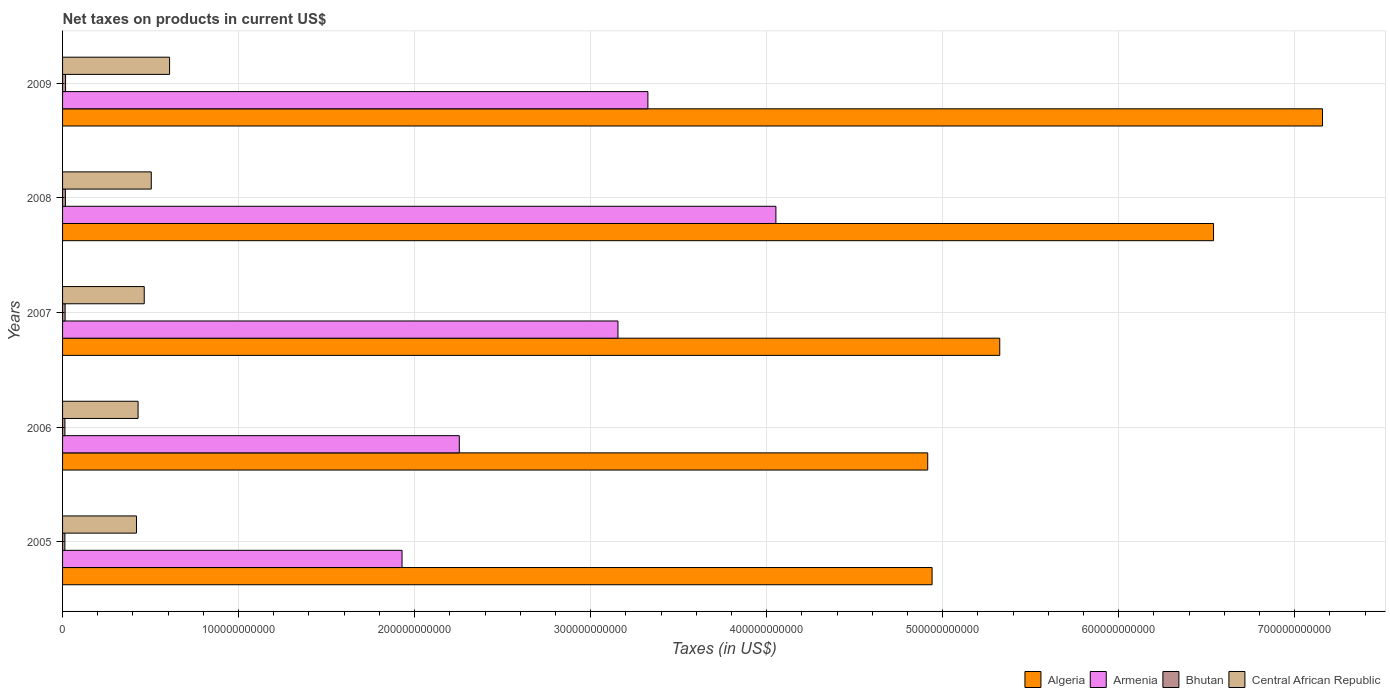How many different coloured bars are there?
Make the answer very short. 4. Are the number of bars on each tick of the Y-axis equal?
Offer a very short reply. Yes. How many bars are there on the 4th tick from the bottom?
Your answer should be very brief. 4. What is the label of the 4th group of bars from the top?
Provide a succinct answer. 2006. In how many cases, is the number of bars for a given year not equal to the number of legend labels?
Offer a very short reply. 0. What is the net taxes on products in Central African Republic in 2008?
Provide a succinct answer. 5.04e+1. Across all years, what is the maximum net taxes on products in Algeria?
Provide a succinct answer. 7.16e+11. Across all years, what is the minimum net taxes on products in Central African Republic?
Your response must be concise. 4.20e+1. What is the total net taxes on products in Bhutan in the graph?
Offer a terse response. 7.42e+09. What is the difference between the net taxes on products in Central African Republic in 2005 and that in 2006?
Your answer should be compact. -9.00e+08. What is the difference between the net taxes on products in Armenia in 2006 and the net taxes on products in Algeria in 2008?
Ensure brevity in your answer.  -4.29e+11. What is the average net taxes on products in Bhutan per year?
Give a very brief answer. 1.48e+09. In the year 2007, what is the difference between the net taxes on products in Bhutan and net taxes on products in Algeria?
Offer a very short reply. -5.31e+11. In how many years, is the net taxes on products in Armenia greater than 540000000000 US$?
Your answer should be compact. 0. What is the ratio of the net taxes on products in Armenia in 2007 to that in 2008?
Offer a terse response. 0.78. What is the difference between the highest and the second highest net taxes on products in Central African Republic?
Make the answer very short. 1.04e+1. What is the difference between the highest and the lowest net taxes on products in Armenia?
Your answer should be very brief. 2.12e+11. In how many years, is the net taxes on products in Armenia greater than the average net taxes on products in Armenia taken over all years?
Keep it short and to the point. 3. Is the sum of the net taxes on products in Armenia in 2006 and 2007 greater than the maximum net taxes on products in Central African Republic across all years?
Your answer should be very brief. Yes. What does the 1st bar from the top in 2009 represents?
Your answer should be very brief. Central African Republic. What does the 3rd bar from the bottom in 2006 represents?
Ensure brevity in your answer.  Bhutan. Are all the bars in the graph horizontal?
Keep it short and to the point. Yes. How many years are there in the graph?
Offer a very short reply. 5. What is the difference between two consecutive major ticks on the X-axis?
Your answer should be very brief. 1.00e+11. Are the values on the major ticks of X-axis written in scientific E-notation?
Ensure brevity in your answer.  No. Does the graph contain grids?
Ensure brevity in your answer.  Yes. How many legend labels are there?
Offer a terse response. 4. How are the legend labels stacked?
Keep it short and to the point. Horizontal. What is the title of the graph?
Provide a succinct answer. Net taxes on products in current US$. Does "Belgium" appear as one of the legend labels in the graph?
Your response must be concise. No. What is the label or title of the X-axis?
Make the answer very short. Taxes (in US$). What is the label or title of the Y-axis?
Give a very brief answer. Years. What is the Taxes (in US$) of Algeria in 2005?
Offer a very short reply. 4.94e+11. What is the Taxes (in US$) of Armenia in 2005?
Provide a short and direct response. 1.93e+11. What is the Taxes (in US$) in Bhutan in 2005?
Your response must be concise. 1.32e+09. What is the Taxes (in US$) of Central African Republic in 2005?
Provide a succinct answer. 4.20e+1. What is the Taxes (in US$) of Algeria in 2006?
Your response must be concise. 4.92e+11. What is the Taxes (in US$) in Armenia in 2006?
Make the answer very short. 2.25e+11. What is the Taxes (in US$) in Bhutan in 2006?
Offer a very short reply. 1.34e+09. What is the Taxes (in US$) of Central African Republic in 2006?
Keep it short and to the point. 4.29e+1. What is the Taxes (in US$) in Algeria in 2007?
Your response must be concise. 5.32e+11. What is the Taxes (in US$) in Armenia in 2007?
Your answer should be compact. 3.16e+11. What is the Taxes (in US$) in Bhutan in 2007?
Provide a succinct answer. 1.44e+09. What is the Taxes (in US$) in Central African Republic in 2007?
Your answer should be compact. 4.64e+1. What is the Taxes (in US$) of Algeria in 2008?
Your answer should be very brief. 6.54e+11. What is the Taxes (in US$) in Armenia in 2008?
Make the answer very short. 4.05e+11. What is the Taxes (in US$) of Bhutan in 2008?
Offer a terse response. 1.61e+09. What is the Taxes (in US$) of Central African Republic in 2008?
Make the answer very short. 5.04e+1. What is the Taxes (in US$) of Algeria in 2009?
Provide a succinct answer. 7.16e+11. What is the Taxes (in US$) of Armenia in 2009?
Offer a very short reply. 3.33e+11. What is the Taxes (in US$) in Bhutan in 2009?
Ensure brevity in your answer.  1.70e+09. What is the Taxes (in US$) of Central African Republic in 2009?
Make the answer very short. 6.08e+1. Across all years, what is the maximum Taxes (in US$) of Algeria?
Give a very brief answer. 7.16e+11. Across all years, what is the maximum Taxes (in US$) of Armenia?
Your answer should be very brief. 4.05e+11. Across all years, what is the maximum Taxes (in US$) of Bhutan?
Offer a very short reply. 1.70e+09. Across all years, what is the maximum Taxes (in US$) of Central African Republic?
Keep it short and to the point. 6.08e+1. Across all years, what is the minimum Taxes (in US$) in Algeria?
Offer a terse response. 4.92e+11. Across all years, what is the minimum Taxes (in US$) in Armenia?
Offer a very short reply. 1.93e+11. Across all years, what is the minimum Taxes (in US$) in Bhutan?
Keep it short and to the point. 1.32e+09. Across all years, what is the minimum Taxes (in US$) in Central African Republic?
Make the answer very short. 4.20e+1. What is the total Taxes (in US$) in Algeria in the graph?
Offer a very short reply. 2.89e+12. What is the total Taxes (in US$) in Armenia in the graph?
Offer a terse response. 1.47e+12. What is the total Taxes (in US$) in Bhutan in the graph?
Make the answer very short. 7.42e+09. What is the total Taxes (in US$) in Central African Republic in the graph?
Offer a terse response. 2.42e+11. What is the difference between the Taxes (in US$) in Algeria in 2005 and that in 2006?
Ensure brevity in your answer.  2.48e+09. What is the difference between the Taxes (in US$) of Armenia in 2005 and that in 2006?
Offer a terse response. -3.25e+1. What is the difference between the Taxes (in US$) in Bhutan in 2005 and that in 2006?
Provide a succinct answer. -1.97e+07. What is the difference between the Taxes (in US$) of Central African Republic in 2005 and that in 2006?
Offer a very short reply. -9.00e+08. What is the difference between the Taxes (in US$) in Algeria in 2005 and that in 2007?
Give a very brief answer. -3.84e+1. What is the difference between the Taxes (in US$) of Armenia in 2005 and that in 2007?
Offer a very short reply. -1.23e+11. What is the difference between the Taxes (in US$) of Bhutan in 2005 and that in 2007?
Provide a short and direct response. -1.25e+08. What is the difference between the Taxes (in US$) of Central African Republic in 2005 and that in 2007?
Give a very brief answer. -4.40e+09. What is the difference between the Taxes (in US$) of Algeria in 2005 and that in 2008?
Your response must be concise. -1.60e+11. What is the difference between the Taxes (in US$) in Armenia in 2005 and that in 2008?
Give a very brief answer. -2.12e+11. What is the difference between the Taxes (in US$) in Bhutan in 2005 and that in 2008?
Provide a succinct answer. -2.95e+08. What is the difference between the Taxes (in US$) of Central African Republic in 2005 and that in 2008?
Keep it short and to the point. -8.40e+09. What is the difference between the Taxes (in US$) of Algeria in 2005 and that in 2009?
Your answer should be compact. -2.22e+11. What is the difference between the Taxes (in US$) in Armenia in 2005 and that in 2009?
Make the answer very short. -1.40e+11. What is the difference between the Taxes (in US$) in Bhutan in 2005 and that in 2009?
Give a very brief answer. -3.87e+08. What is the difference between the Taxes (in US$) in Central African Republic in 2005 and that in 2009?
Your answer should be very brief. -1.88e+1. What is the difference between the Taxes (in US$) of Algeria in 2006 and that in 2007?
Offer a very short reply. -4.09e+1. What is the difference between the Taxes (in US$) of Armenia in 2006 and that in 2007?
Make the answer very short. -9.01e+1. What is the difference between the Taxes (in US$) of Bhutan in 2006 and that in 2007?
Offer a terse response. -1.05e+08. What is the difference between the Taxes (in US$) in Central African Republic in 2006 and that in 2007?
Offer a terse response. -3.50e+09. What is the difference between the Taxes (in US$) in Algeria in 2006 and that in 2008?
Your response must be concise. -1.62e+11. What is the difference between the Taxes (in US$) in Armenia in 2006 and that in 2008?
Provide a succinct answer. -1.80e+11. What is the difference between the Taxes (in US$) in Bhutan in 2006 and that in 2008?
Offer a very short reply. -2.76e+08. What is the difference between the Taxes (in US$) in Central African Republic in 2006 and that in 2008?
Make the answer very short. -7.50e+09. What is the difference between the Taxes (in US$) of Algeria in 2006 and that in 2009?
Keep it short and to the point. -2.24e+11. What is the difference between the Taxes (in US$) of Armenia in 2006 and that in 2009?
Provide a short and direct response. -1.07e+11. What is the difference between the Taxes (in US$) in Bhutan in 2006 and that in 2009?
Provide a short and direct response. -3.67e+08. What is the difference between the Taxes (in US$) in Central African Republic in 2006 and that in 2009?
Your answer should be compact. -1.79e+1. What is the difference between the Taxes (in US$) of Algeria in 2007 and that in 2008?
Offer a terse response. -1.21e+11. What is the difference between the Taxes (in US$) in Armenia in 2007 and that in 2008?
Provide a short and direct response. -8.97e+1. What is the difference between the Taxes (in US$) in Bhutan in 2007 and that in 2008?
Provide a short and direct response. -1.71e+08. What is the difference between the Taxes (in US$) in Central African Republic in 2007 and that in 2008?
Offer a very short reply. -4.00e+09. What is the difference between the Taxes (in US$) of Algeria in 2007 and that in 2009?
Make the answer very short. -1.83e+11. What is the difference between the Taxes (in US$) in Armenia in 2007 and that in 2009?
Provide a succinct answer. -1.70e+1. What is the difference between the Taxes (in US$) of Bhutan in 2007 and that in 2009?
Provide a succinct answer. -2.62e+08. What is the difference between the Taxes (in US$) of Central African Republic in 2007 and that in 2009?
Provide a succinct answer. -1.44e+1. What is the difference between the Taxes (in US$) in Algeria in 2008 and that in 2009?
Your response must be concise. -6.19e+1. What is the difference between the Taxes (in US$) in Armenia in 2008 and that in 2009?
Your answer should be very brief. 7.27e+1. What is the difference between the Taxes (in US$) of Bhutan in 2008 and that in 2009?
Keep it short and to the point. -9.18e+07. What is the difference between the Taxes (in US$) in Central African Republic in 2008 and that in 2009?
Provide a short and direct response. -1.04e+1. What is the difference between the Taxes (in US$) in Algeria in 2005 and the Taxes (in US$) in Armenia in 2006?
Keep it short and to the point. 2.69e+11. What is the difference between the Taxes (in US$) in Algeria in 2005 and the Taxes (in US$) in Bhutan in 2006?
Give a very brief answer. 4.93e+11. What is the difference between the Taxes (in US$) of Algeria in 2005 and the Taxes (in US$) of Central African Republic in 2006?
Offer a very short reply. 4.51e+11. What is the difference between the Taxes (in US$) in Armenia in 2005 and the Taxes (in US$) in Bhutan in 2006?
Keep it short and to the point. 1.92e+11. What is the difference between the Taxes (in US$) in Armenia in 2005 and the Taxes (in US$) in Central African Republic in 2006?
Offer a very short reply. 1.50e+11. What is the difference between the Taxes (in US$) in Bhutan in 2005 and the Taxes (in US$) in Central African Republic in 2006?
Ensure brevity in your answer.  -4.16e+1. What is the difference between the Taxes (in US$) in Algeria in 2005 and the Taxes (in US$) in Armenia in 2007?
Your answer should be very brief. 1.78e+11. What is the difference between the Taxes (in US$) in Algeria in 2005 and the Taxes (in US$) in Bhutan in 2007?
Offer a terse response. 4.93e+11. What is the difference between the Taxes (in US$) in Algeria in 2005 and the Taxes (in US$) in Central African Republic in 2007?
Offer a very short reply. 4.48e+11. What is the difference between the Taxes (in US$) in Armenia in 2005 and the Taxes (in US$) in Bhutan in 2007?
Your answer should be compact. 1.91e+11. What is the difference between the Taxes (in US$) of Armenia in 2005 and the Taxes (in US$) of Central African Republic in 2007?
Give a very brief answer. 1.46e+11. What is the difference between the Taxes (in US$) in Bhutan in 2005 and the Taxes (in US$) in Central African Republic in 2007?
Give a very brief answer. -4.51e+1. What is the difference between the Taxes (in US$) of Algeria in 2005 and the Taxes (in US$) of Armenia in 2008?
Provide a short and direct response. 8.87e+1. What is the difference between the Taxes (in US$) in Algeria in 2005 and the Taxes (in US$) in Bhutan in 2008?
Give a very brief answer. 4.92e+11. What is the difference between the Taxes (in US$) in Algeria in 2005 and the Taxes (in US$) in Central African Republic in 2008?
Your response must be concise. 4.44e+11. What is the difference between the Taxes (in US$) in Armenia in 2005 and the Taxes (in US$) in Bhutan in 2008?
Your response must be concise. 1.91e+11. What is the difference between the Taxes (in US$) of Armenia in 2005 and the Taxes (in US$) of Central African Republic in 2008?
Provide a short and direct response. 1.42e+11. What is the difference between the Taxes (in US$) of Bhutan in 2005 and the Taxes (in US$) of Central African Republic in 2008?
Keep it short and to the point. -4.91e+1. What is the difference between the Taxes (in US$) in Algeria in 2005 and the Taxes (in US$) in Armenia in 2009?
Ensure brevity in your answer.  1.61e+11. What is the difference between the Taxes (in US$) of Algeria in 2005 and the Taxes (in US$) of Bhutan in 2009?
Your response must be concise. 4.92e+11. What is the difference between the Taxes (in US$) of Algeria in 2005 and the Taxes (in US$) of Central African Republic in 2009?
Make the answer very short. 4.33e+11. What is the difference between the Taxes (in US$) of Armenia in 2005 and the Taxes (in US$) of Bhutan in 2009?
Provide a short and direct response. 1.91e+11. What is the difference between the Taxes (in US$) in Armenia in 2005 and the Taxes (in US$) in Central African Republic in 2009?
Make the answer very short. 1.32e+11. What is the difference between the Taxes (in US$) of Bhutan in 2005 and the Taxes (in US$) of Central African Republic in 2009?
Keep it short and to the point. -5.95e+1. What is the difference between the Taxes (in US$) of Algeria in 2006 and the Taxes (in US$) of Armenia in 2007?
Your answer should be compact. 1.76e+11. What is the difference between the Taxes (in US$) of Algeria in 2006 and the Taxes (in US$) of Bhutan in 2007?
Provide a short and direct response. 4.90e+11. What is the difference between the Taxes (in US$) of Algeria in 2006 and the Taxes (in US$) of Central African Republic in 2007?
Ensure brevity in your answer.  4.45e+11. What is the difference between the Taxes (in US$) of Armenia in 2006 and the Taxes (in US$) of Bhutan in 2007?
Provide a short and direct response. 2.24e+11. What is the difference between the Taxes (in US$) of Armenia in 2006 and the Taxes (in US$) of Central African Republic in 2007?
Make the answer very short. 1.79e+11. What is the difference between the Taxes (in US$) in Bhutan in 2006 and the Taxes (in US$) in Central African Republic in 2007?
Provide a short and direct response. -4.51e+1. What is the difference between the Taxes (in US$) of Algeria in 2006 and the Taxes (in US$) of Armenia in 2008?
Give a very brief answer. 8.63e+1. What is the difference between the Taxes (in US$) of Algeria in 2006 and the Taxes (in US$) of Bhutan in 2008?
Offer a terse response. 4.90e+11. What is the difference between the Taxes (in US$) of Algeria in 2006 and the Taxes (in US$) of Central African Republic in 2008?
Your answer should be compact. 4.41e+11. What is the difference between the Taxes (in US$) of Armenia in 2006 and the Taxes (in US$) of Bhutan in 2008?
Make the answer very short. 2.24e+11. What is the difference between the Taxes (in US$) of Armenia in 2006 and the Taxes (in US$) of Central African Republic in 2008?
Ensure brevity in your answer.  1.75e+11. What is the difference between the Taxes (in US$) in Bhutan in 2006 and the Taxes (in US$) in Central African Republic in 2008?
Your answer should be very brief. -4.91e+1. What is the difference between the Taxes (in US$) of Algeria in 2006 and the Taxes (in US$) of Armenia in 2009?
Your answer should be compact. 1.59e+11. What is the difference between the Taxes (in US$) of Algeria in 2006 and the Taxes (in US$) of Bhutan in 2009?
Make the answer very short. 4.90e+11. What is the difference between the Taxes (in US$) of Algeria in 2006 and the Taxes (in US$) of Central African Republic in 2009?
Offer a very short reply. 4.31e+11. What is the difference between the Taxes (in US$) of Armenia in 2006 and the Taxes (in US$) of Bhutan in 2009?
Your answer should be very brief. 2.24e+11. What is the difference between the Taxes (in US$) in Armenia in 2006 and the Taxes (in US$) in Central African Republic in 2009?
Provide a short and direct response. 1.65e+11. What is the difference between the Taxes (in US$) of Bhutan in 2006 and the Taxes (in US$) of Central African Republic in 2009?
Make the answer very short. -5.95e+1. What is the difference between the Taxes (in US$) in Algeria in 2007 and the Taxes (in US$) in Armenia in 2008?
Keep it short and to the point. 1.27e+11. What is the difference between the Taxes (in US$) of Algeria in 2007 and the Taxes (in US$) of Bhutan in 2008?
Give a very brief answer. 5.31e+11. What is the difference between the Taxes (in US$) in Algeria in 2007 and the Taxes (in US$) in Central African Republic in 2008?
Provide a succinct answer. 4.82e+11. What is the difference between the Taxes (in US$) of Armenia in 2007 and the Taxes (in US$) of Bhutan in 2008?
Provide a succinct answer. 3.14e+11. What is the difference between the Taxes (in US$) of Armenia in 2007 and the Taxes (in US$) of Central African Republic in 2008?
Provide a succinct answer. 2.65e+11. What is the difference between the Taxes (in US$) of Bhutan in 2007 and the Taxes (in US$) of Central African Republic in 2008?
Your response must be concise. -4.90e+1. What is the difference between the Taxes (in US$) in Algeria in 2007 and the Taxes (in US$) in Armenia in 2009?
Your answer should be very brief. 2.00e+11. What is the difference between the Taxes (in US$) in Algeria in 2007 and the Taxes (in US$) in Bhutan in 2009?
Offer a very short reply. 5.31e+11. What is the difference between the Taxes (in US$) in Algeria in 2007 and the Taxes (in US$) in Central African Republic in 2009?
Your answer should be compact. 4.72e+11. What is the difference between the Taxes (in US$) of Armenia in 2007 and the Taxes (in US$) of Bhutan in 2009?
Provide a succinct answer. 3.14e+11. What is the difference between the Taxes (in US$) of Armenia in 2007 and the Taxes (in US$) of Central African Republic in 2009?
Your answer should be very brief. 2.55e+11. What is the difference between the Taxes (in US$) in Bhutan in 2007 and the Taxes (in US$) in Central African Republic in 2009?
Your response must be concise. -5.94e+1. What is the difference between the Taxes (in US$) in Algeria in 2008 and the Taxes (in US$) in Armenia in 2009?
Provide a short and direct response. 3.21e+11. What is the difference between the Taxes (in US$) of Algeria in 2008 and the Taxes (in US$) of Bhutan in 2009?
Your answer should be compact. 6.52e+11. What is the difference between the Taxes (in US$) in Algeria in 2008 and the Taxes (in US$) in Central African Republic in 2009?
Provide a short and direct response. 5.93e+11. What is the difference between the Taxes (in US$) in Armenia in 2008 and the Taxes (in US$) in Bhutan in 2009?
Provide a succinct answer. 4.04e+11. What is the difference between the Taxes (in US$) of Armenia in 2008 and the Taxes (in US$) of Central African Republic in 2009?
Offer a very short reply. 3.44e+11. What is the difference between the Taxes (in US$) in Bhutan in 2008 and the Taxes (in US$) in Central African Republic in 2009?
Your answer should be very brief. -5.92e+1. What is the average Taxes (in US$) of Algeria per year?
Offer a terse response. 5.78e+11. What is the average Taxes (in US$) in Armenia per year?
Your response must be concise. 2.94e+11. What is the average Taxes (in US$) of Bhutan per year?
Your answer should be compact. 1.48e+09. What is the average Taxes (in US$) of Central African Republic per year?
Your response must be concise. 4.85e+1. In the year 2005, what is the difference between the Taxes (in US$) in Algeria and Taxes (in US$) in Armenia?
Your answer should be compact. 3.01e+11. In the year 2005, what is the difference between the Taxes (in US$) in Algeria and Taxes (in US$) in Bhutan?
Your response must be concise. 4.93e+11. In the year 2005, what is the difference between the Taxes (in US$) in Algeria and Taxes (in US$) in Central African Republic?
Provide a short and direct response. 4.52e+11. In the year 2005, what is the difference between the Taxes (in US$) of Armenia and Taxes (in US$) of Bhutan?
Provide a succinct answer. 1.92e+11. In the year 2005, what is the difference between the Taxes (in US$) of Armenia and Taxes (in US$) of Central African Republic?
Your answer should be very brief. 1.51e+11. In the year 2005, what is the difference between the Taxes (in US$) in Bhutan and Taxes (in US$) in Central African Republic?
Your answer should be very brief. -4.07e+1. In the year 2006, what is the difference between the Taxes (in US$) of Algeria and Taxes (in US$) of Armenia?
Give a very brief answer. 2.66e+11. In the year 2006, what is the difference between the Taxes (in US$) in Algeria and Taxes (in US$) in Bhutan?
Provide a short and direct response. 4.90e+11. In the year 2006, what is the difference between the Taxes (in US$) in Algeria and Taxes (in US$) in Central African Republic?
Offer a terse response. 4.49e+11. In the year 2006, what is the difference between the Taxes (in US$) in Armenia and Taxes (in US$) in Bhutan?
Your answer should be compact. 2.24e+11. In the year 2006, what is the difference between the Taxes (in US$) in Armenia and Taxes (in US$) in Central African Republic?
Offer a very short reply. 1.83e+11. In the year 2006, what is the difference between the Taxes (in US$) in Bhutan and Taxes (in US$) in Central African Republic?
Offer a very short reply. -4.16e+1. In the year 2007, what is the difference between the Taxes (in US$) in Algeria and Taxes (in US$) in Armenia?
Provide a short and direct response. 2.17e+11. In the year 2007, what is the difference between the Taxes (in US$) of Algeria and Taxes (in US$) of Bhutan?
Provide a succinct answer. 5.31e+11. In the year 2007, what is the difference between the Taxes (in US$) in Algeria and Taxes (in US$) in Central African Republic?
Make the answer very short. 4.86e+11. In the year 2007, what is the difference between the Taxes (in US$) of Armenia and Taxes (in US$) of Bhutan?
Give a very brief answer. 3.14e+11. In the year 2007, what is the difference between the Taxes (in US$) of Armenia and Taxes (in US$) of Central African Republic?
Offer a terse response. 2.69e+11. In the year 2007, what is the difference between the Taxes (in US$) in Bhutan and Taxes (in US$) in Central African Republic?
Offer a very short reply. -4.50e+1. In the year 2008, what is the difference between the Taxes (in US$) in Algeria and Taxes (in US$) in Armenia?
Ensure brevity in your answer.  2.49e+11. In the year 2008, what is the difference between the Taxes (in US$) in Algeria and Taxes (in US$) in Bhutan?
Your answer should be very brief. 6.52e+11. In the year 2008, what is the difference between the Taxes (in US$) in Algeria and Taxes (in US$) in Central African Republic?
Offer a terse response. 6.04e+11. In the year 2008, what is the difference between the Taxes (in US$) in Armenia and Taxes (in US$) in Bhutan?
Your response must be concise. 4.04e+11. In the year 2008, what is the difference between the Taxes (in US$) of Armenia and Taxes (in US$) of Central African Republic?
Your answer should be compact. 3.55e+11. In the year 2008, what is the difference between the Taxes (in US$) in Bhutan and Taxes (in US$) in Central African Republic?
Offer a terse response. -4.88e+1. In the year 2009, what is the difference between the Taxes (in US$) in Algeria and Taxes (in US$) in Armenia?
Provide a succinct answer. 3.83e+11. In the year 2009, what is the difference between the Taxes (in US$) of Algeria and Taxes (in US$) of Bhutan?
Give a very brief answer. 7.14e+11. In the year 2009, what is the difference between the Taxes (in US$) of Algeria and Taxes (in US$) of Central African Republic?
Ensure brevity in your answer.  6.55e+11. In the year 2009, what is the difference between the Taxes (in US$) of Armenia and Taxes (in US$) of Bhutan?
Give a very brief answer. 3.31e+11. In the year 2009, what is the difference between the Taxes (in US$) of Armenia and Taxes (in US$) of Central African Republic?
Provide a short and direct response. 2.72e+11. In the year 2009, what is the difference between the Taxes (in US$) of Bhutan and Taxes (in US$) of Central African Republic?
Keep it short and to the point. -5.91e+1. What is the ratio of the Taxes (in US$) in Armenia in 2005 to that in 2006?
Your answer should be very brief. 0.86. What is the ratio of the Taxes (in US$) in Bhutan in 2005 to that in 2006?
Provide a succinct answer. 0.99. What is the ratio of the Taxes (in US$) in Central African Republic in 2005 to that in 2006?
Provide a succinct answer. 0.98. What is the ratio of the Taxes (in US$) in Algeria in 2005 to that in 2007?
Provide a succinct answer. 0.93. What is the ratio of the Taxes (in US$) in Armenia in 2005 to that in 2007?
Provide a succinct answer. 0.61. What is the ratio of the Taxes (in US$) of Bhutan in 2005 to that in 2007?
Provide a succinct answer. 0.91. What is the ratio of the Taxes (in US$) of Central African Republic in 2005 to that in 2007?
Your answer should be compact. 0.91. What is the ratio of the Taxes (in US$) of Algeria in 2005 to that in 2008?
Offer a very short reply. 0.76. What is the ratio of the Taxes (in US$) in Armenia in 2005 to that in 2008?
Make the answer very short. 0.48. What is the ratio of the Taxes (in US$) in Bhutan in 2005 to that in 2008?
Keep it short and to the point. 0.82. What is the ratio of the Taxes (in US$) in Central African Republic in 2005 to that in 2008?
Ensure brevity in your answer.  0.83. What is the ratio of the Taxes (in US$) in Algeria in 2005 to that in 2009?
Ensure brevity in your answer.  0.69. What is the ratio of the Taxes (in US$) of Armenia in 2005 to that in 2009?
Provide a short and direct response. 0.58. What is the ratio of the Taxes (in US$) of Bhutan in 2005 to that in 2009?
Your answer should be compact. 0.77. What is the ratio of the Taxes (in US$) of Central African Republic in 2005 to that in 2009?
Offer a terse response. 0.69. What is the ratio of the Taxes (in US$) of Algeria in 2006 to that in 2007?
Offer a terse response. 0.92. What is the ratio of the Taxes (in US$) in Armenia in 2006 to that in 2007?
Your answer should be very brief. 0.71. What is the ratio of the Taxes (in US$) in Bhutan in 2006 to that in 2007?
Provide a succinct answer. 0.93. What is the ratio of the Taxes (in US$) in Central African Republic in 2006 to that in 2007?
Make the answer very short. 0.92. What is the ratio of the Taxes (in US$) of Algeria in 2006 to that in 2008?
Your answer should be compact. 0.75. What is the ratio of the Taxes (in US$) of Armenia in 2006 to that in 2008?
Give a very brief answer. 0.56. What is the ratio of the Taxes (in US$) of Bhutan in 2006 to that in 2008?
Make the answer very short. 0.83. What is the ratio of the Taxes (in US$) of Central African Republic in 2006 to that in 2008?
Offer a very short reply. 0.85. What is the ratio of the Taxes (in US$) in Algeria in 2006 to that in 2009?
Ensure brevity in your answer.  0.69. What is the ratio of the Taxes (in US$) of Armenia in 2006 to that in 2009?
Your response must be concise. 0.68. What is the ratio of the Taxes (in US$) in Bhutan in 2006 to that in 2009?
Give a very brief answer. 0.78. What is the ratio of the Taxes (in US$) in Central African Republic in 2006 to that in 2009?
Make the answer very short. 0.71. What is the ratio of the Taxes (in US$) in Algeria in 2007 to that in 2008?
Ensure brevity in your answer.  0.81. What is the ratio of the Taxes (in US$) of Armenia in 2007 to that in 2008?
Your answer should be very brief. 0.78. What is the ratio of the Taxes (in US$) in Bhutan in 2007 to that in 2008?
Offer a terse response. 0.89. What is the ratio of the Taxes (in US$) of Central African Republic in 2007 to that in 2008?
Offer a terse response. 0.92. What is the ratio of the Taxes (in US$) of Algeria in 2007 to that in 2009?
Give a very brief answer. 0.74. What is the ratio of the Taxes (in US$) of Armenia in 2007 to that in 2009?
Your response must be concise. 0.95. What is the ratio of the Taxes (in US$) of Bhutan in 2007 to that in 2009?
Give a very brief answer. 0.85. What is the ratio of the Taxes (in US$) in Central African Republic in 2007 to that in 2009?
Keep it short and to the point. 0.76. What is the ratio of the Taxes (in US$) of Algeria in 2008 to that in 2009?
Provide a short and direct response. 0.91. What is the ratio of the Taxes (in US$) in Armenia in 2008 to that in 2009?
Keep it short and to the point. 1.22. What is the ratio of the Taxes (in US$) of Bhutan in 2008 to that in 2009?
Make the answer very short. 0.95. What is the ratio of the Taxes (in US$) of Central African Republic in 2008 to that in 2009?
Give a very brief answer. 0.83. What is the difference between the highest and the second highest Taxes (in US$) of Algeria?
Make the answer very short. 6.19e+1. What is the difference between the highest and the second highest Taxes (in US$) in Armenia?
Provide a succinct answer. 7.27e+1. What is the difference between the highest and the second highest Taxes (in US$) of Bhutan?
Make the answer very short. 9.18e+07. What is the difference between the highest and the second highest Taxes (in US$) in Central African Republic?
Your answer should be compact. 1.04e+1. What is the difference between the highest and the lowest Taxes (in US$) of Algeria?
Offer a terse response. 2.24e+11. What is the difference between the highest and the lowest Taxes (in US$) in Armenia?
Provide a succinct answer. 2.12e+11. What is the difference between the highest and the lowest Taxes (in US$) in Bhutan?
Ensure brevity in your answer.  3.87e+08. What is the difference between the highest and the lowest Taxes (in US$) in Central African Republic?
Your response must be concise. 1.88e+1. 